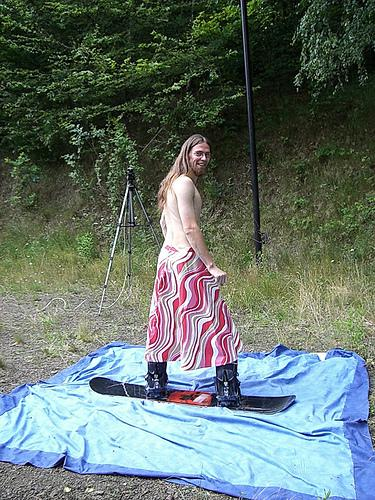Question: where was the picture taken?
Choices:
A. The mountain.
B. The beach.
C. The lake.
D. A park.
Answer with the letter. Answer: D Question: what is the color of the snowboard?
Choices:
A. Brown.
B. Black.
C. White.
D. Blue.
Answer with the letter. Answer: B Question: what color is the blanket?
Choices:
A. Pink.
B. Blue.
C. Purple.
D. Yellow.
Answer with the letter. Answer: B 